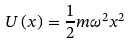<formula> <loc_0><loc_0><loc_500><loc_500>U \left ( x \right ) = \frac { 1 } { 2 } m \omega ^ { 2 } x ^ { 2 }</formula> 